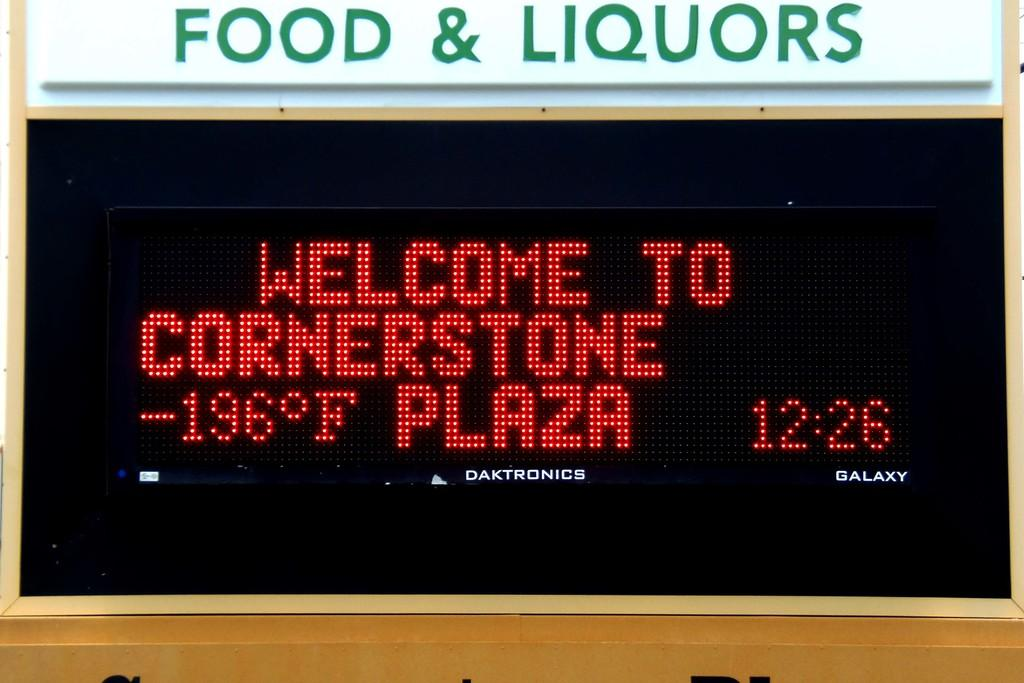<image>
Offer a succinct explanation of the picture presented. A large sign for food and liquors that says welcome to cornerstone plaza. 